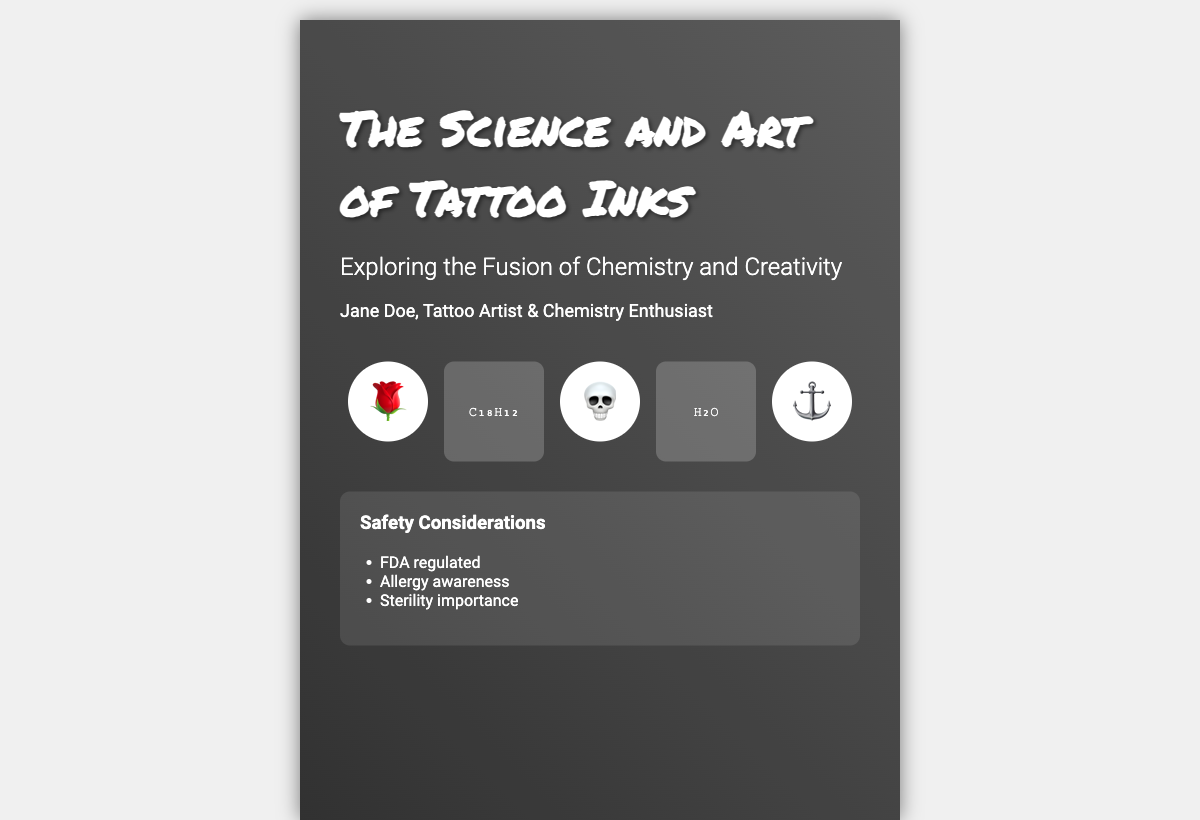What is the title of the book? The title is presented prominently on the cover, emphasizing its focus on tattoo inks.
Answer: The Science and Art of Tattoo Inks Who is the author of the book? The author's name is displayed below the title, indicating her background and expertise.
Answer: Jane Doe What does the subtitle refer to? The subtitle elaborates on the book's theme, highlighting the integration of two important fields.
Answer: Exploring the Fusion of Chemistry and Creativity What safety consideration is mentioned? The safety section lists important aspects related to the use of tattoo inks.
Answer: FDA regulated How many tattoo elements are represented on the cover? The cover features a visually distinct representation of tattoo elements.
Answer: Three What chemical formula is displayed alongside the tattoo elements? The cover includes molecular structures that reflect the chemistry involved in tattoo inks.
Answer: C₁₈H₁₂ What color scheme is used for the book cover background? The background gradient sets the tone for the artistic theme of the document.
Answer: Black to gray What shape are the tattoo elements? The design of the tattoo elements has a consistent shape that complements the overall aesthetics.
Answer: Circular What is the main theme conveyed in the subtitle? The subtitle suggests the dual focus of the book, combining both scientific and artistic perspectives.
Answer: Chemistry and Creativity 